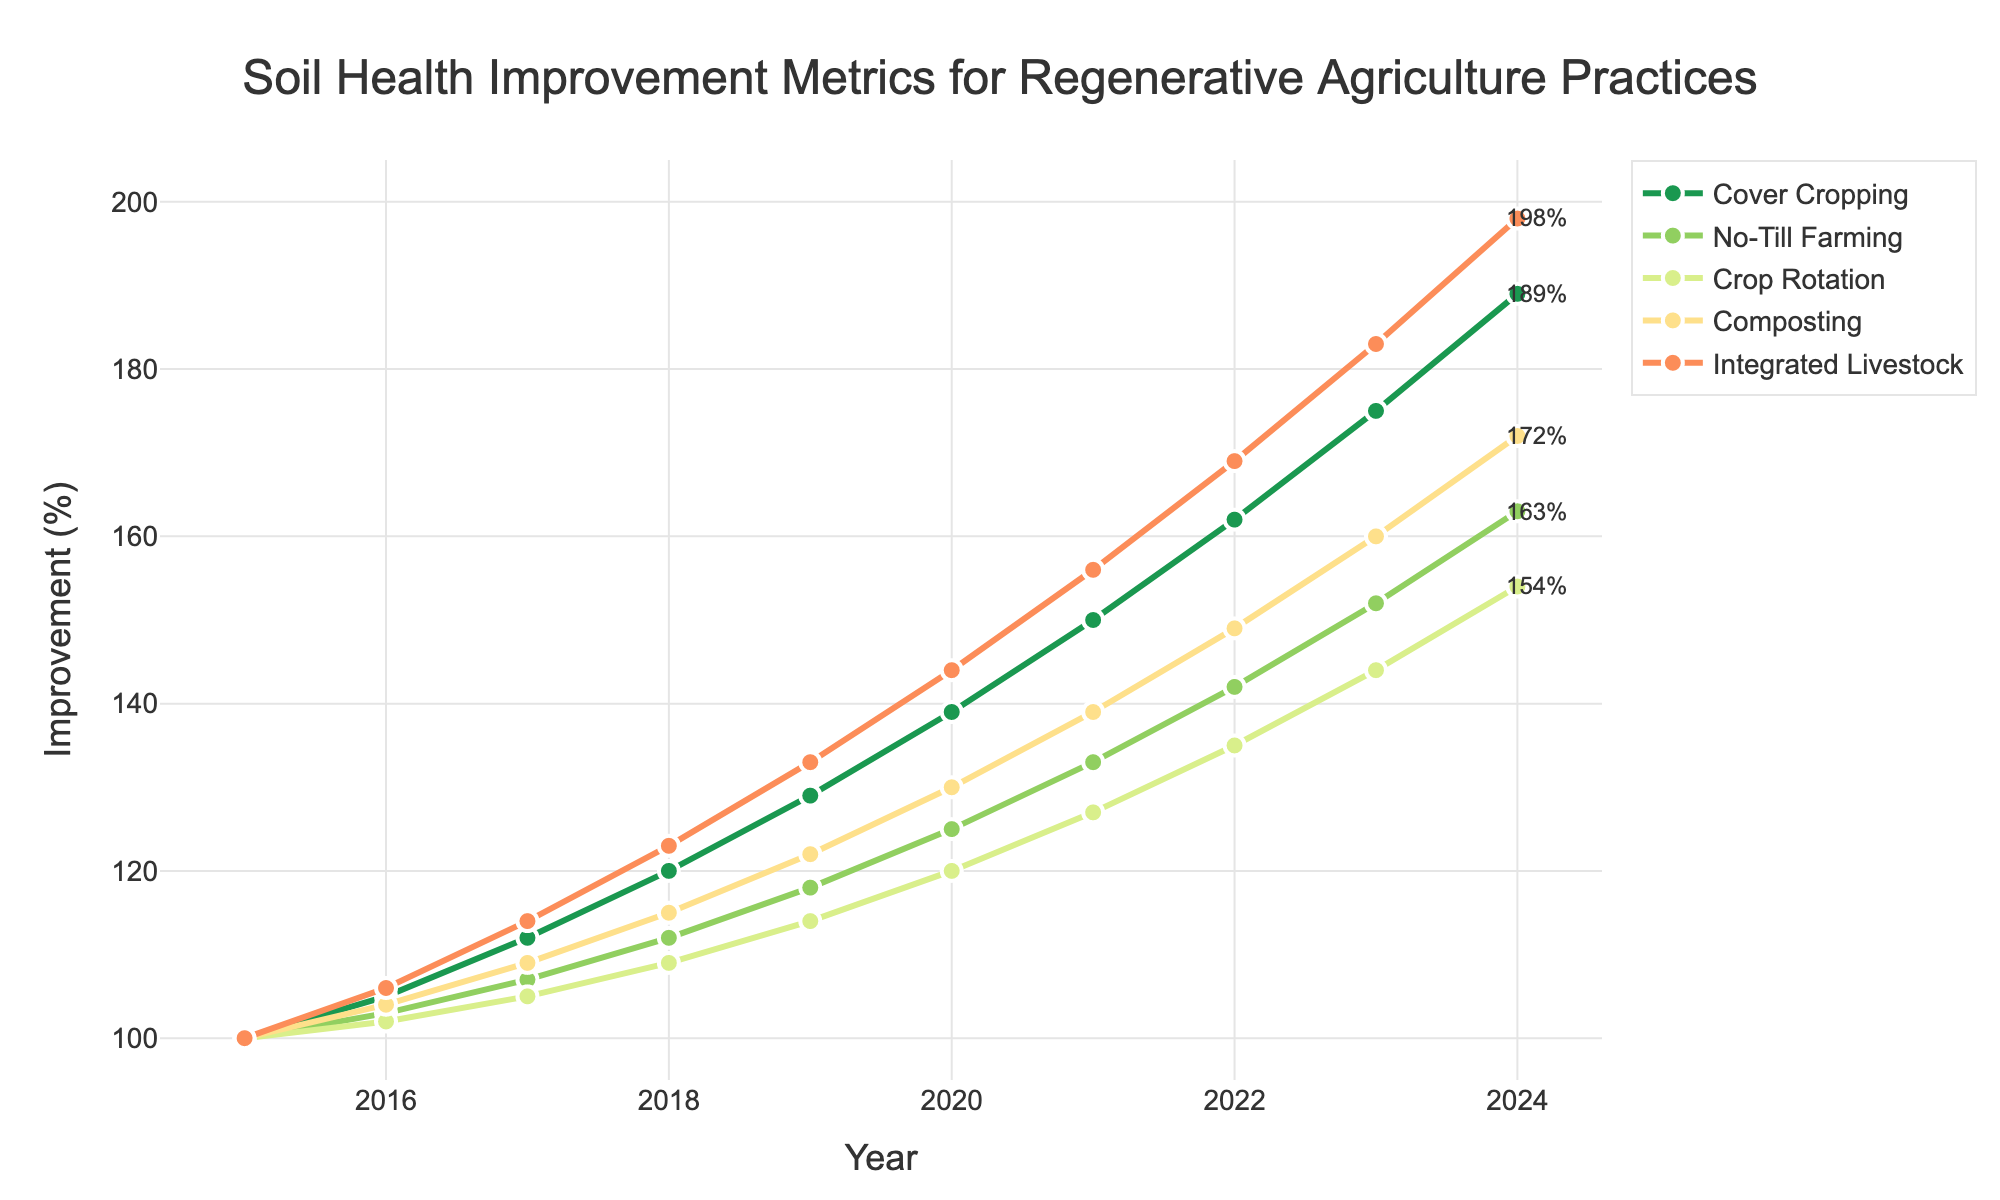what practice shows the greatest soil health improvement over the entire period? By observing the endpoints of each line in the figure, the practice with the highest improvement in 2024 can be determined. The 'Integrated Livestock' practice reaches the highest value, indicating the greatest improvement.
Answer: Integrated Livestock Which year did Crop Rotation and No-Till Farming show equal improvements? By locating the point where both lines for 'Crop Rotation' and 'No-Till Farming' intersect, we can determine the year. This intersection point is visually observed in the year 2017.
Answer: 2017 What is the difference in soil health improvement between Cover Cropping and Composting in 2022? Identify the improvement values for 'Cover Cropping' and 'Composting' in 2022. The values are 162 and 149 respectively. The difference is 162 - 149 = 13.
Answer: 13 Which practice had the smallest improvement from 2015 to 2024? Calculate the difference in improvement percentages between 2015 and 2024 for each practice. The practice with the lowest increase over this period is 'No-Till Farming' with an increase of 63% (163-100).
Answer: No-Till Farming What is the total soil health improvement in 2023 for all practices combined? Summing the values of all practices in 2023: (175 for Cover Cropping) + (152 for No-Till Farming) + (144 for Crop Rotation) + (160 for Composting) + (183 for Integrated Livestock) = 814.
Answer: 814 Which year did the practice of Composting first surpass 120 in soil health improvement? Identify the year where the 'Composting' line first goes above 120. The figure shows this happening for the first time in the year 2019.
Answer: 2019 How many years did it take for Integrated Livestock practice to double its soil health improvement from its 2015 value? The initial value for 'Integrated Livestock' in 2015 was 100. Doubling this improvement means reaching 200. By tracking the 'Integrated Livestock' line, it surpasses 200 by 2024, i.e., it takes 9 years.
Answer: 9 What is the average soil health improvement for Cover Cropping over the entire period? Sum the values of 'Cover Cropping' improvements for each year and divide by the number of years: (100+105+112+120+129+139+150+162+175+189) / 10 = 1381 / 10 = 138.1.
Answer: 138.1 Which practice has the most consistent year-over-year improvement? By assessing the visual consistency of each practice's line, 'Compost' shows the most uniform slope with steady incremental increases, indicating consistent improvement.
Answer: Composting 